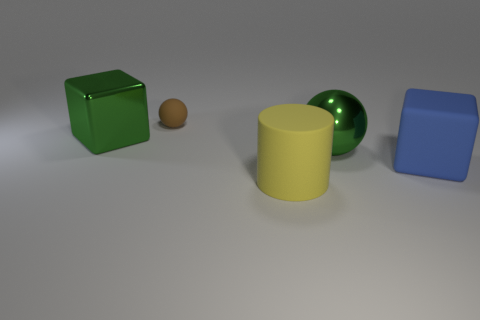Is the number of tiny green matte cubes greater than the number of large blue objects?
Ensure brevity in your answer.  No. There is a rubber object that is behind the matte cylinder and to the right of the tiny brown rubber object; what is its size?
Keep it short and to the point. Large. There is a big block that is the same color as the big ball; what material is it?
Your answer should be compact. Metal. Are there an equal number of tiny balls that are to the right of the matte block and tiny brown spheres?
Provide a succinct answer. No. Is the size of the brown sphere the same as the yellow rubber cylinder?
Keep it short and to the point. No. What color is the rubber object that is both to the left of the blue block and in front of the brown sphere?
Offer a very short reply. Yellow. What material is the block that is left of the rubber thing that is in front of the large blue matte thing?
Provide a succinct answer. Metal. The other thing that is the same shape as the small rubber thing is what size?
Offer a terse response. Large. There is a block that is to the left of the brown rubber sphere; is it the same color as the small rubber ball?
Offer a very short reply. No. Is the number of big shiny blocks less than the number of large green things?
Provide a short and direct response. Yes. 